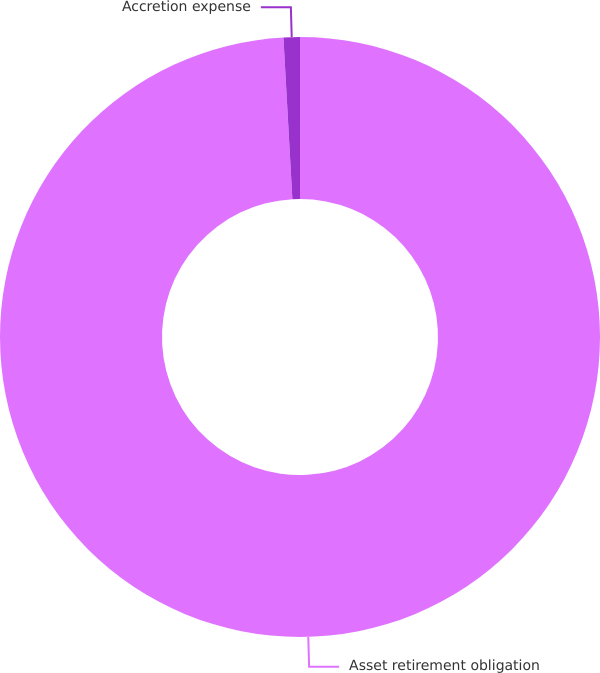Convert chart to OTSL. <chart><loc_0><loc_0><loc_500><loc_500><pie_chart><fcel>Asset retirement obligation<fcel>Accretion expense<nl><fcel>99.12%<fcel>0.88%<nl></chart> 